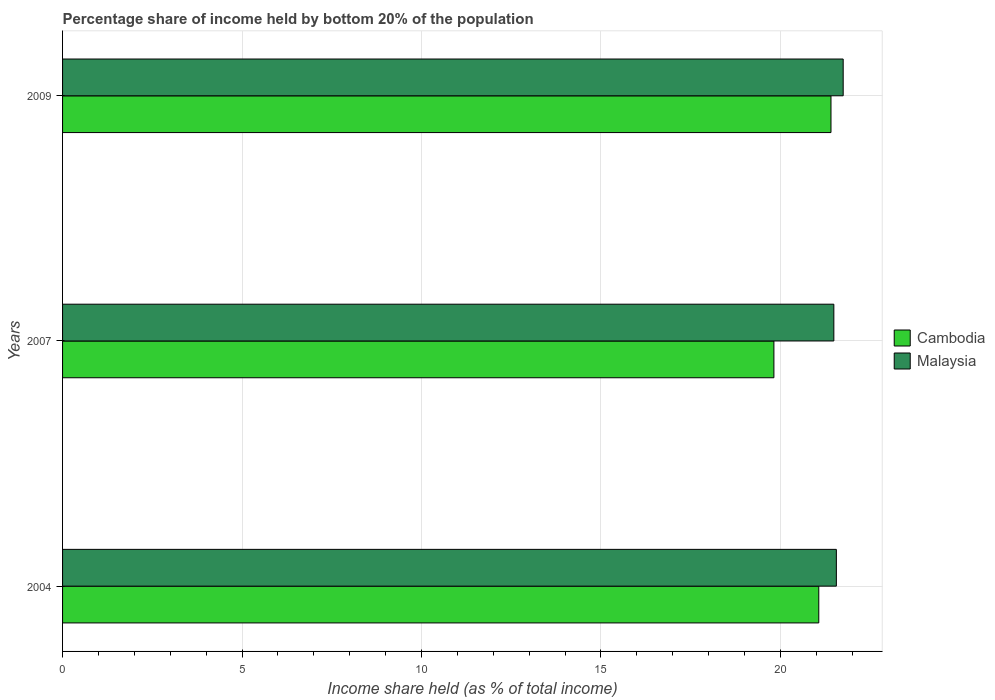How many different coloured bars are there?
Offer a terse response. 2. How many groups of bars are there?
Your answer should be compact. 3. Are the number of bars per tick equal to the number of legend labels?
Ensure brevity in your answer.  Yes. How many bars are there on the 3rd tick from the top?
Your response must be concise. 2. How many bars are there on the 1st tick from the bottom?
Your response must be concise. 2. What is the label of the 1st group of bars from the top?
Your response must be concise. 2009. In how many cases, is the number of bars for a given year not equal to the number of legend labels?
Give a very brief answer. 0. What is the share of income held by bottom 20% of the population in Cambodia in 2007?
Offer a terse response. 19.82. Across all years, what is the maximum share of income held by bottom 20% of the population in Malaysia?
Provide a short and direct response. 21.75. Across all years, what is the minimum share of income held by bottom 20% of the population in Cambodia?
Your answer should be very brief. 19.82. In which year was the share of income held by bottom 20% of the population in Malaysia maximum?
Keep it short and to the point. 2009. What is the total share of income held by bottom 20% of the population in Cambodia in the graph?
Ensure brevity in your answer.  62.3. What is the difference between the share of income held by bottom 20% of the population in Cambodia in 2007 and that in 2009?
Offer a very short reply. -1.59. What is the difference between the share of income held by bottom 20% of the population in Malaysia in 2004 and the share of income held by bottom 20% of the population in Cambodia in 2009?
Make the answer very short. 0.15. What is the average share of income held by bottom 20% of the population in Cambodia per year?
Your answer should be very brief. 20.77. In the year 2009, what is the difference between the share of income held by bottom 20% of the population in Malaysia and share of income held by bottom 20% of the population in Cambodia?
Provide a succinct answer. 0.34. In how many years, is the share of income held by bottom 20% of the population in Malaysia greater than 6 %?
Your response must be concise. 3. What is the ratio of the share of income held by bottom 20% of the population in Cambodia in 2007 to that in 2009?
Give a very brief answer. 0.93. Is the difference between the share of income held by bottom 20% of the population in Malaysia in 2004 and 2009 greater than the difference between the share of income held by bottom 20% of the population in Cambodia in 2004 and 2009?
Ensure brevity in your answer.  Yes. What is the difference between the highest and the second highest share of income held by bottom 20% of the population in Malaysia?
Offer a terse response. 0.19. What is the difference between the highest and the lowest share of income held by bottom 20% of the population in Malaysia?
Offer a very short reply. 0.26. In how many years, is the share of income held by bottom 20% of the population in Cambodia greater than the average share of income held by bottom 20% of the population in Cambodia taken over all years?
Your answer should be compact. 2. What does the 1st bar from the top in 2009 represents?
Keep it short and to the point. Malaysia. What does the 2nd bar from the bottom in 2009 represents?
Offer a terse response. Malaysia. How many bars are there?
Ensure brevity in your answer.  6. Does the graph contain any zero values?
Offer a terse response. No. Does the graph contain grids?
Ensure brevity in your answer.  Yes. How many legend labels are there?
Keep it short and to the point. 2. How are the legend labels stacked?
Your answer should be compact. Vertical. What is the title of the graph?
Your answer should be very brief. Percentage share of income held by bottom 20% of the population. What is the label or title of the X-axis?
Keep it short and to the point. Income share held (as % of total income). What is the label or title of the Y-axis?
Your answer should be compact. Years. What is the Income share held (as % of total income) in Cambodia in 2004?
Give a very brief answer. 21.07. What is the Income share held (as % of total income) in Malaysia in 2004?
Provide a succinct answer. 21.56. What is the Income share held (as % of total income) in Cambodia in 2007?
Ensure brevity in your answer.  19.82. What is the Income share held (as % of total income) of Malaysia in 2007?
Provide a succinct answer. 21.49. What is the Income share held (as % of total income) in Cambodia in 2009?
Your response must be concise. 21.41. What is the Income share held (as % of total income) of Malaysia in 2009?
Your answer should be very brief. 21.75. Across all years, what is the maximum Income share held (as % of total income) in Cambodia?
Ensure brevity in your answer.  21.41. Across all years, what is the maximum Income share held (as % of total income) of Malaysia?
Your answer should be very brief. 21.75. Across all years, what is the minimum Income share held (as % of total income) in Cambodia?
Offer a terse response. 19.82. Across all years, what is the minimum Income share held (as % of total income) in Malaysia?
Offer a very short reply. 21.49. What is the total Income share held (as % of total income) of Cambodia in the graph?
Keep it short and to the point. 62.3. What is the total Income share held (as % of total income) of Malaysia in the graph?
Keep it short and to the point. 64.8. What is the difference between the Income share held (as % of total income) in Malaysia in 2004 and that in 2007?
Ensure brevity in your answer.  0.07. What is the difference between the Income share held (as % of total income) in Cambodia in 2004 and that in 2009?
Provide a short and direct response. -0.34. What is the difference between the Income share held (as % of total income) in Malaysia in 2004 and that in 2009?
Provide a succinct answer. -0.19. What is the difference between the Income share held (as % of total income) of Cambodia in 2007 and that in 2009?
Offer a very short reply. -1.59. What is the difference between the Income share held (as % of total income) in Malaysia in 2007 and that in 2009?
Your response must be concise. -0.26. What is the difference between the Income share held (as % of total income) in Cambodia in 2004 and the Income share held (as % of total income) in Malaysia in 2007?
Your answer should be compact. -0.42. What is the difference between the Income share held (as % of total income) of Cambodia in 2004 and the Income share held (as % of total income) of Malaysia in 2009?
Provide a short and direct response. -0.68. What is the difference between the Income share held (as % of total income) in Cambodia in 2007 and the Income share held (as % of total income) in Malaysia in 2009?
Your answer should be very brief. -1.93. What is the average Income share held (as % of total income) of Cambodia per year?
Provide a short and direct response. 20.77. What is the average Income share held (as % of total income) in Malaysia per year?
Offer a very short reply. 21.6. In the year 2004, what is the difference between the Income share held (as % of total income) in Cambodia and Income share held (as % of total income) in Malaysia?
Your answer should be very brief. -0.49. In the year 2007, what is the difference between the Income share held (as % of total income) of Cambodia and Income share held (as % of total income) of Malaysia?
Make the answer very short. -1.67. In the year 2009, what is the difference between the Income share held (as % of total income) of Cambodia and Income share held (as % of total income) of Malaysia?
Provide a short and direct response. -0.34. What is the ratio of the Income share held (as % of total income) in Cambodia in 2004 to that in 2007?
Make the answer very short. 1.06. What is the ratio of the Income share held (as % of total income) of Malaysia in 2004 to that in 2007?
Your answer should be compact. 1. What is the ratio of the Income share held (as % of total income) of Cambodia in 2004 to that in 2009?
Your response must be concise. 0.98. What is the ratio of the Income share held (as % of total income) in Cambodia in 2007 to that in 2009?
Your answer should be compact. 0.93. What is the difference between the highest and the second highest Income share held (as % of total income) of Cambodia?
Ensure brevity in your answer.  0.34. What is the difference between the highest and the second highest Income share held (as % of total income) in Malaysia?
Your answer should be compact. 0.19. What is the difference between the highest and the lowest Income share held (as % of total income) of Cambodia?
Make the answer very short. 1.59. What is the difference between the highest and the lowest Income share held (as % of total income) of Malaysia?
Offer a terse response. 0.26. 